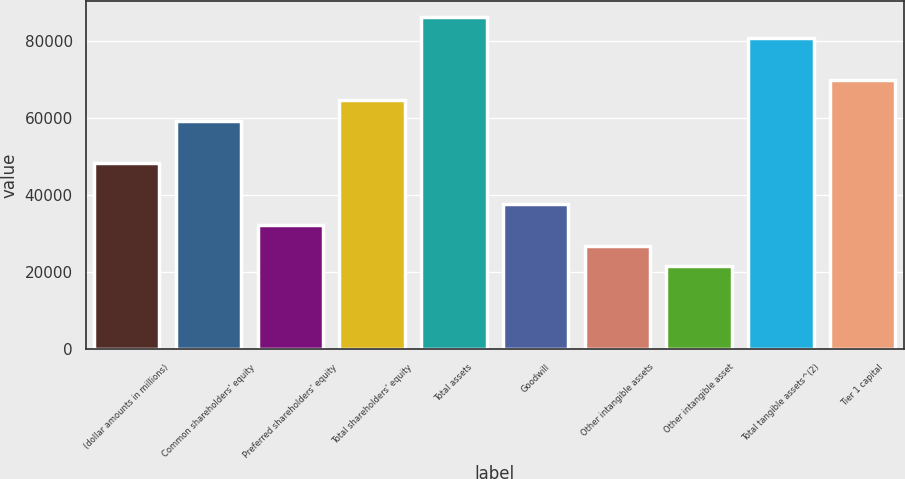Convert chart. <chart><loc_0><loc_0><loc_500><loc_500><bar_chart><fcel>(dollar amounts in millions)<fcel>Common shareholders' equity<fcel>Preferred shareholders' equity<fcel>Total shareholders' equity<fcel>Total assets<fcel>Goodwill<fcel>Other intangible assets<fcel>Other intangible asset<fcel>Total tangible assets^(2)<fcel>Tier 1 capital<nl><fcel>48438.7<fcel>59201.2<fcel>32295<fcel>64582.4<fcel>86107.4<fcel>37676.2<fcel>26913.8<fcel>21532.5<fcel>80726.2<fcel>69963.7<nl></chart> 